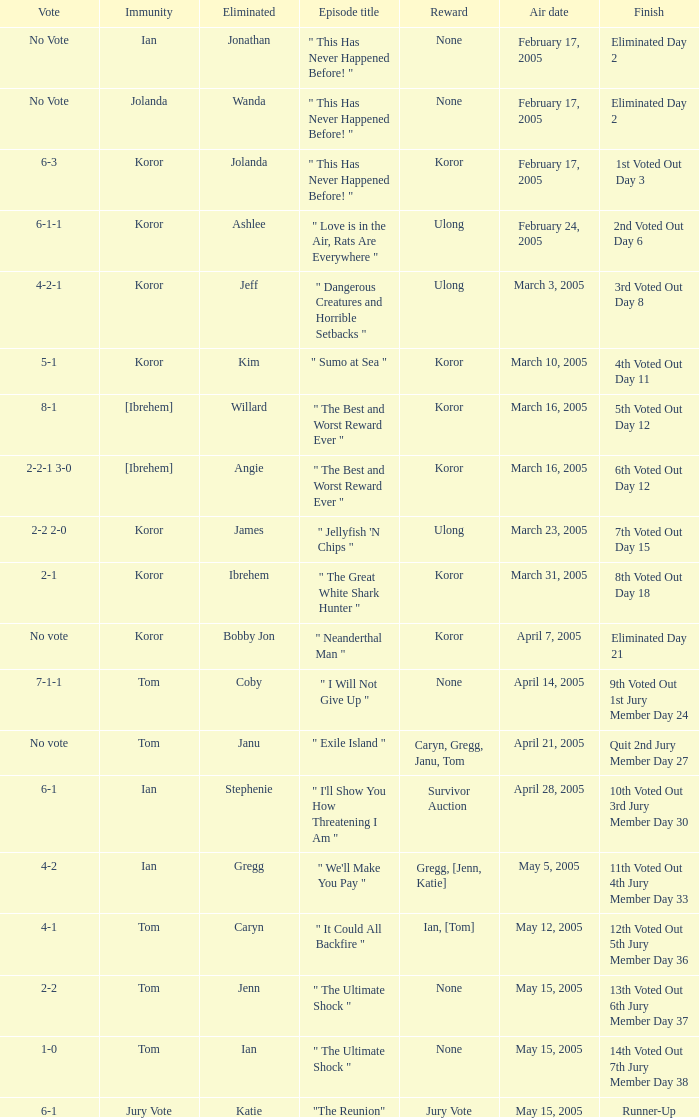What was the vote tally on the episode aired May 5, 2005? 4-2. I'm looking to parse the entire table for insights. Could you assist me with that? {'header': ['Vote', 'Immunity', 'Eliminated', 'Episode title', 'Reward', 'Air date', 'Finish'], 'rows': [['No Vote', 'Ian', 'Jonathan', '" This Has Never Happened Before! "', 'None', 'February 17, 2005', 'Eliminated Day 2'], ['No Vote', 'Jolanda', 'Wanda', '" This Has Never Happened Before! "', 'None', 'February 17, 2005', 'Eliminated Day 2'], ['6-3', 'Koror', 'Jolanda', '" This Has Never Happened Before! "', 'Koror', 'February 17, 2005', '1st Voted Out Day 3'], ['6-1-1', 'Koror', 'Ashlee', '" Love is in the Air, Rats Are Everywhere "', 'Ulong', 'February 24, 2005', '2nd Voted Out Day 6'], ['4-2-1', 'Koror', 'Jeff', '" Dangerous Creatures and Horrible Setbacks "', 'Ulong', 'March 3, 2005', '3rd Voted Out Day 8'], ['5-1', 'Koror', 'Kim', '" Sumo at Sea "', 'Koror', 'March 10, 2005', '4th Voted Out Day 11'], ['8-1', '[Ibrehem]', 'Willard', '" The Best and Worst Reward Ever "', 'Koror', 'March 16, 2005', '5th Voted Out Day 12'], ['2-2-1 3-0', '[Ibrehem]', 'Angie', '" The Best and Worst Reward Ever "', 'Koror', 'March 16, 2005', '6th Voted Out Day 12'], ['2-2 2-0', 'Koror', 'James', '" Jellyfish \'N Chips "', 'Ulong', 'March 23, 2005', '7th Voted Out Day 15'], ['2-1', 'Koror', 'Ibrehem', '" The Great White Shark Hunter "', 'Koror', 'March 31, 2005', '8th Voted Out Day 18'], ['No vote', 'Koror', 'Bobby Jon', '" Neanderthal Man "', 'Koror', 'April 7, 2005', 'Eliminated Day 21'], ['7-1-1', 'Tom', 'Coby', '" I Will Not Give Up "', 'None', 'April 14, 2005', '9th Voted Out 1st Jury Member Day 24'], ['No vote', 'Tom', 'Janu', '" Exile Island "', 'Caryn, Gregg, Janu, Tom', 'April 21, 2005', 'Quit 2nd Jury Member Day 27'], ['6-1', 'Ian', 'Stephenie', '" I\'ll Show You How Threatening I Am "', 'Survivor Auction', 'April 28, 2005', '10th Voted Out 3rd Jury Member Day 30'], ['4-2', 'Ian', 'Gregg', '" We\'ll Make You Pay "', 'Gregg, [Jenn, Katie]', 'May 5, 2005', '11th Voted Out 4th Jury Member Day 33'], ['4-1', 'Tom', 'Caryn', '" It Could All Backfire "', 'Ian, [Tom]', 'May 12, 2005', '12th Voted Out 5th Jury Member Day 36'], ['2-2', 'Tom', 'Jenn', '" The Ultimate Shock "', 'None', 'May 15, 2005', '13th Voted Out 6th Jury Member Day 37'], ['1-0', 'Tom', 'Ian', '" The Ultimate Shock "', 'None', 'May 15, 2005', '14th Voted Out 7th Jury Member Day 38'], ['6-1', 'Jury Vote', 'Katie', '"The Reunion"', 'Jury Vote', 'May 15, 2005', 'Runner-Up']]} 